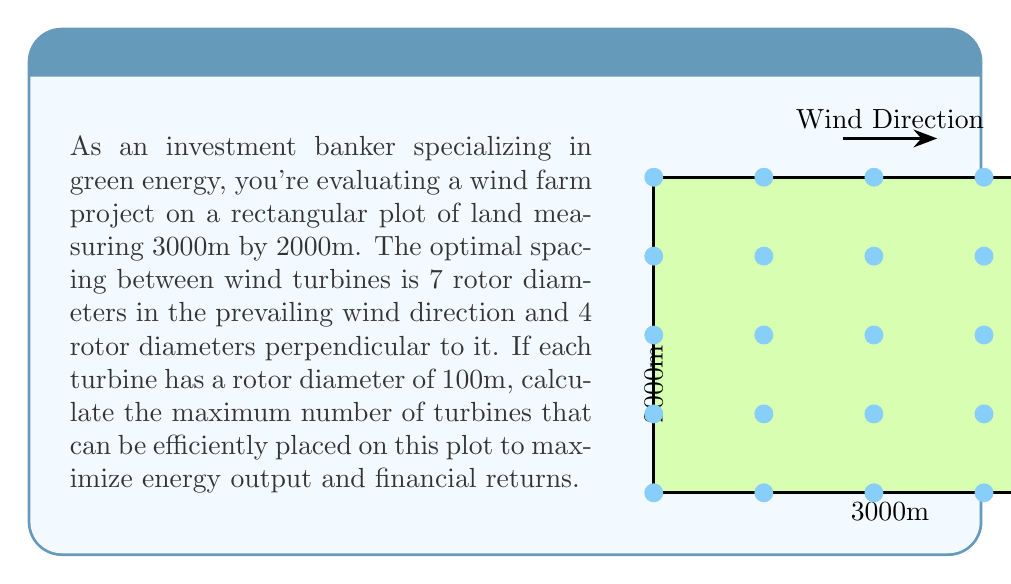Teach me how to tackle this problem. Let's approach this step-by-step:

1) First, we need to calculate the spacing required between turbines:
   - In the prevailing wind direction: $7 \times 100\text{m} = 700\text{m}$
   - Perpendicular to wind direction: $4 \times 100\text{m} = 400\text{m}$

2) Now, let's calculate how many rows and columns of turbines we can fit:
   - Number of columns (along 3000m side): 
     $$\text{Columns} = \left\lfloor\frac{3000\text{m}}{700\text{m}}\right\rfloor = \left\lfloor4.28\right\rfloor = 4$$
   - Number of rows (along 2000m side):
     $$\text{Rows} = \left\lfloor\frac{2000\text{m}}{400\text{m}}\right\rfloor = \left\lfloor5\right\rfloor = 5$$

3) The total number of turbines is the product of rows and columns:
   $$\text{Total Turbines} = \text{Rows} \times \text{Columns} = 5 \times 4 = 20$$

Therefore, the maximum number of turbines that can be efficiently placed on this plot is 20.
Answer: 20 turbines 